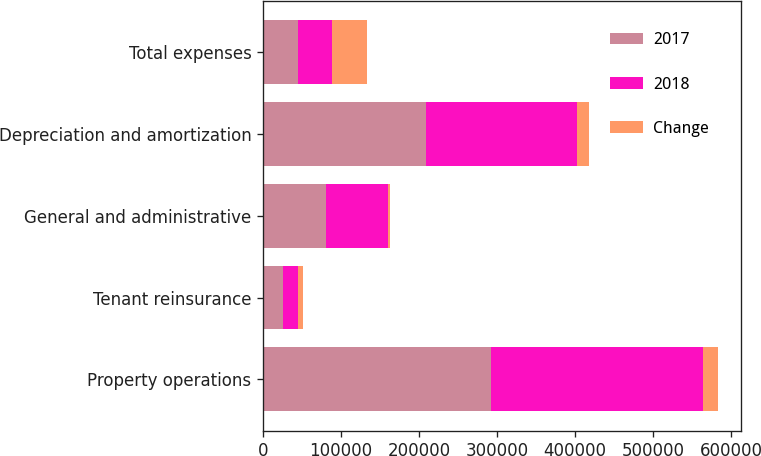<chart> <loc_0><loc_0><loc_500><loc_500><stacked_bar_chart><ecel><fcel>Property operations<fcel>Tenant reinsurance<fcel>General and administrative<fcel>Depreciation and amortization<fcel>Total expenses<nl><fcel>2017<fcel>291695<fcel>25707<fcel>81256<fcel>209050<fcel>44304<nl><fcel>2018<fcel>271974<fcel>19173<fcel>78961<fcel>193296<fcel>44304<nl><fcel>Change<fcel>19721<fcel>6534<fcel>2295<fcel>15754<fcel>44304<nl></chart> 